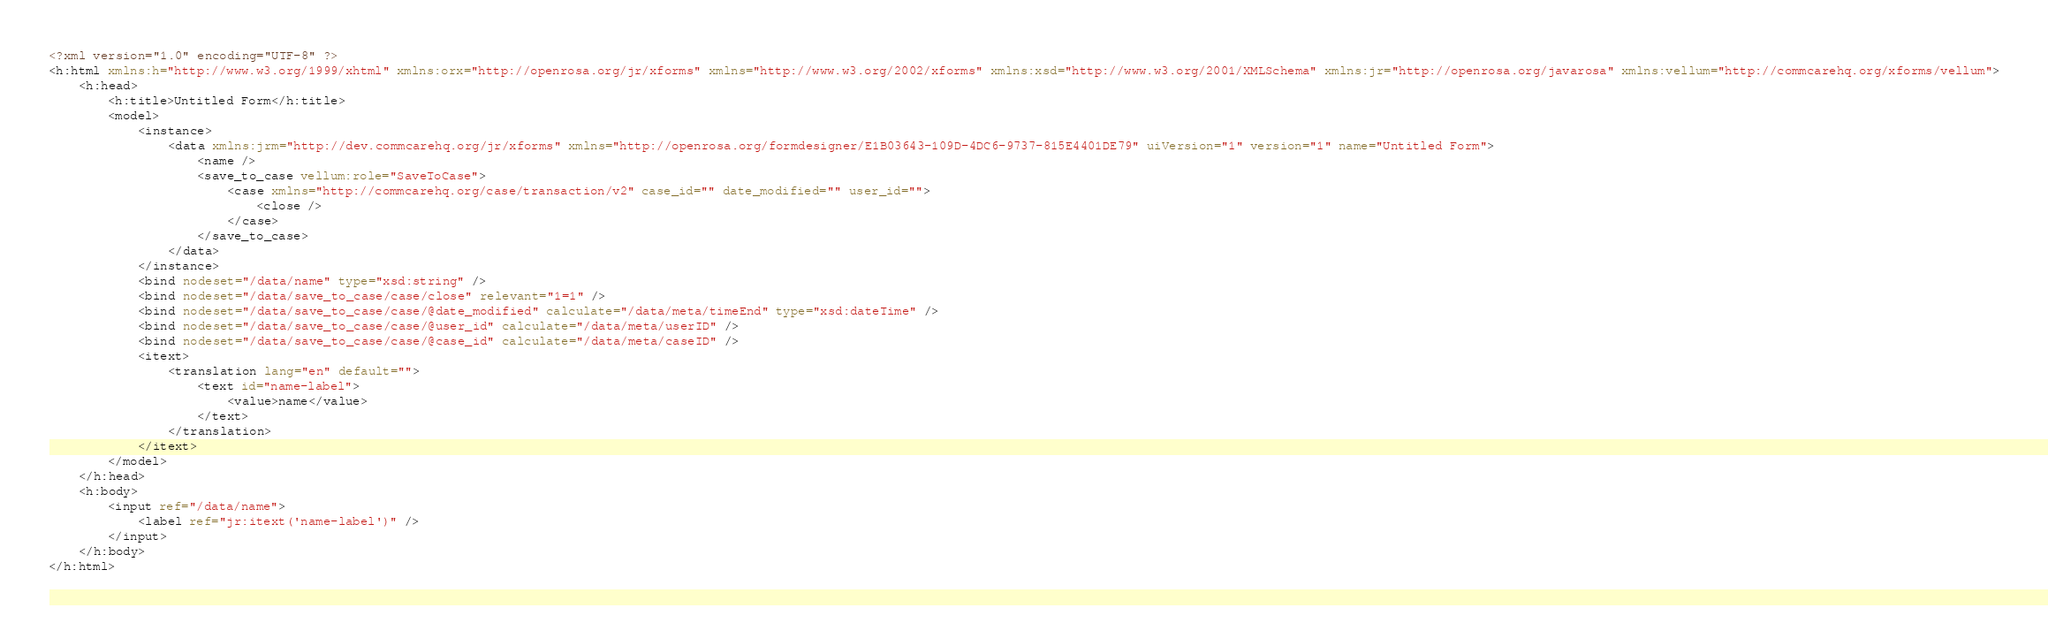Convert code to text. <code><loc_0><loc_0><loc_500><loc_500><_XML_><?xml version="1.0" encoding="UTF-8" ?>
<h:html xmlns:h="http://www.w3.org/1999/xhtml" xmlns:orx="http://openrosa.org/jr/xforms" xmlns="http://www.w3.org/2002/xforms" xmlns:xsd="http://www.w3.org/2001/XMLSchema" xmlns:jr="http://openrosa.org/javarosa" xmlns:vellum="http://commcarehq.org/xforms/vellum">
	<h:head>
		<h:title>Untitled Form</h:title>
		<model>
			<instance>
				<data xmlns:jrm="http://dev.commcarehq.org/jr/xforms" xmlns="http://openrosa.org/formdesigner/E1B03643-109D-4DC6-9737-815E4401DE79" uiVersion="1" version="1" name="Untitled Form">
					<name />
					<save_to_case vellum:role="SaveToCase">
						<case xmlns="http://commcarehq.org/case/transaction/v2" case_id="" date_modified="" user_id="">
							<close />
						</case>
					</save_to_case>
				</data>
			</instance>
			<bind nodeset="/data/name" type="xsd:string" />
			<bind nodeset="/data/save_to_case/case/close" relevant="1=1" />
			<bind nodeset="/data/save_to_case/case/@date_modified" calculate="/data/meta/timeEnd" type="xsd:dateTime" />
			<bind nodeset="/data/save_to_case/case/@user_id" calculate="/data/meta/userID" />
			<bind nodeset="/data/save_to_case/case/@case_id" calculate="/data/meta/caseID" />
			<itext>
				<translation lang="en" default="">
					<text id="name-label">
						<value>name</value>
					</text>
				</translation>
			</itext>
		</model>
	</h:head>
	<h:body>
		<input ref="/data/name">
			<label ref="jr:itext('name-label')" />
		</input>
	</h:body>
</h:html>
</code> 